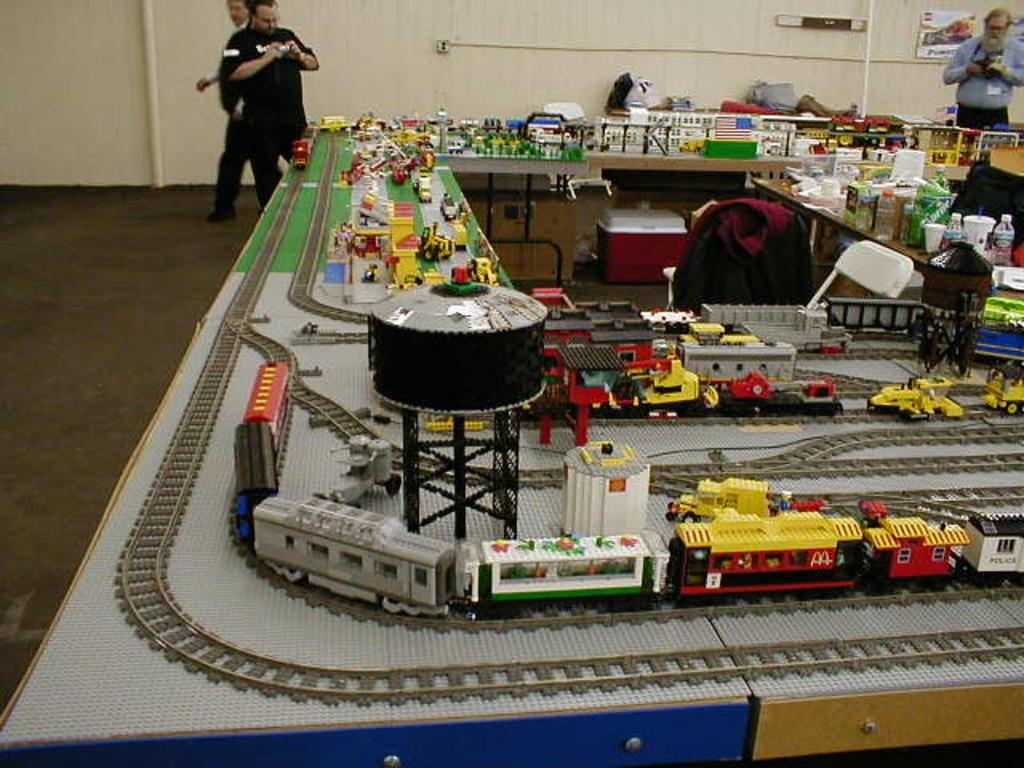What objects are located in the center of the image? There are toy trains, blocks, bottles, a chair, a bag, and a container in the center of the image. What type of objects are these? The objects in the center of the image are toys, household items, and a bag. Can you describe the background of the image? There are persons and a wall visible in the background of the image. How does the ornament in the image reflect the light during the rainstorm? There is no ornament present in the image, and it is not raining in the image. 